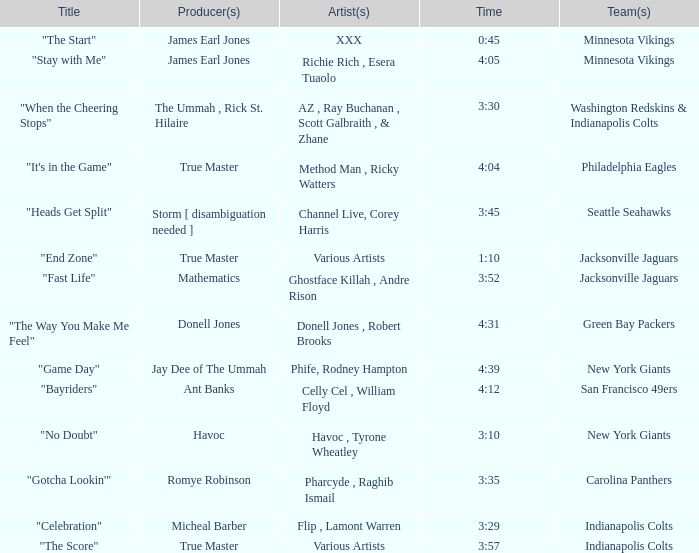Which artist is responsible for the new york giants' song "no doubt"? Havoc , Tyrone Wheatley. 